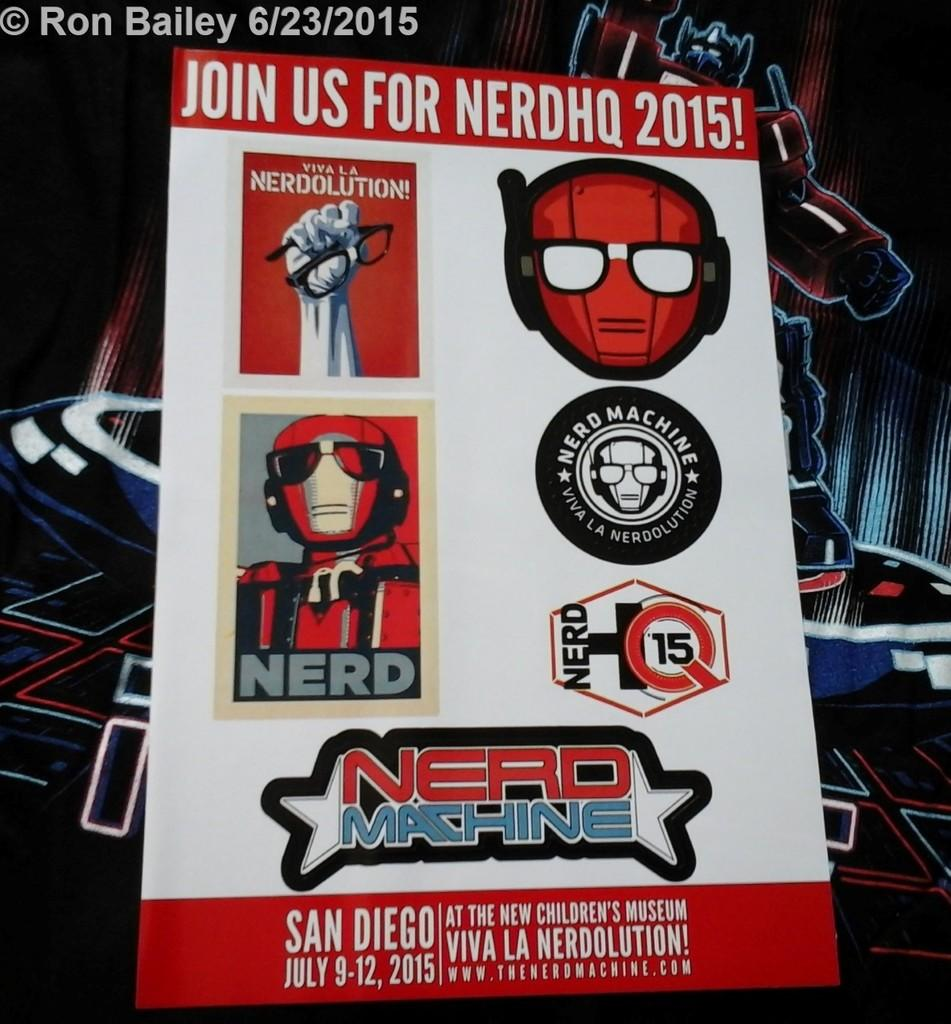Provide a one-sentence caption for the provided image. A poster in primarily red and white advertising something called NerdHQ 2015. 